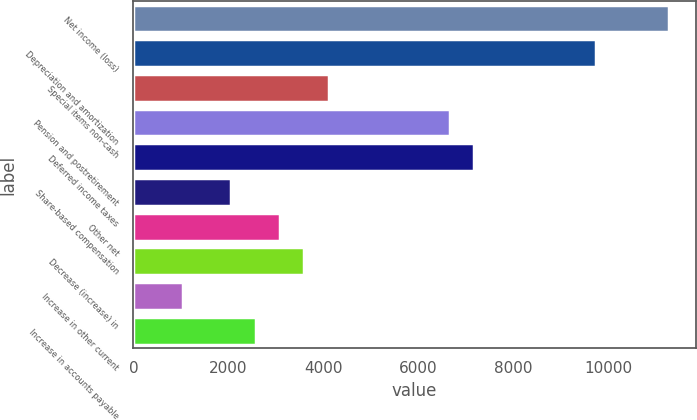Convert chart to OTSL. <chart><loc_0><loc_0><loc_500><loc_500><bar_chart><fcel>Net income (loss)<fcel>Depreciation and amortization<fcel>Special items non-cash<fcel>Pension and postretirement<fcel>Deferred income taxes<fcel>Share-based compensation<fcel>Other net<fcel>Decrease (increase) in<fcel>Increase in other current<fcel>Increase in accounts payable<nl><fcel>11281.6<fcel>9744.7<fcel>4109.4<fcel>6670.9<fcel>7183.2<fcel>2060.2<fcel>3084.8<fcel>3597.1<fcel>1035.6<fcel>2572.5<nl></chart> 